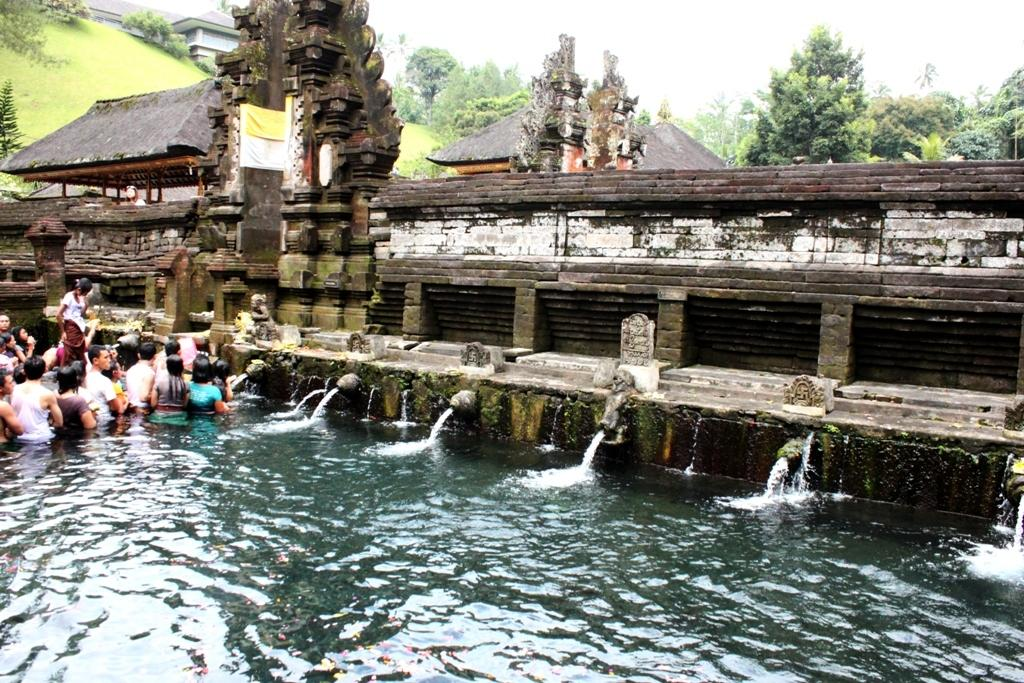What is the primary element visible in the image? There is water in the image. Can you describe the people in the image? There is a group of people in the image. What type of structures can be seen in the image? There are buildings in the image. What type of vegetation is present in the image? There is grass and trees in the image. What is visible at the top of the image? The sky is visible at the top of the image. What type of zephyr can be seen blowing through the produce in the image? There is no zephyr or produce present in the image. How many boots are visible in the image? There are no boots visible in the image. 